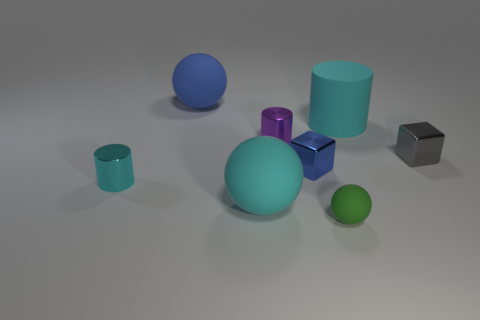Is there a tiny blue shiny thing that has the same shape as the tiny green object?
Your answer should be very brief. No. What number of other things are the same shape as the purple object?
Keep it short and to the point. 2. Is the color of the rubber cylinder the same as the tiny matte object?
Your response must be concise. No. Is the number of large blue rubber objects less than the number of cyan things?
Offer a very short reply. Yes. There is a sphere behind the tiny cyan metal object; what is it made of?
Offer a very short reply. Rubber. What is the material of the purple thing that is the same size as the gray object?
Make the answer very short. Metal. What is the large sphere to the right of the rubber thing to the left of the cyan rubber object in front of the small cyan cylinder made of?
Offer a very short reply. Rubber. Does the cyan rubber object in front of the gray metal object have the same size as the tiny purple metallic cylinder?
Your response must be concise. No. Is the number of metallic blocks greater than the number of tiny blue objects?
Keep it short and to the point. Yes. What number of tiny things are blue things or green matte objects?
Make the answer very short. 2. 